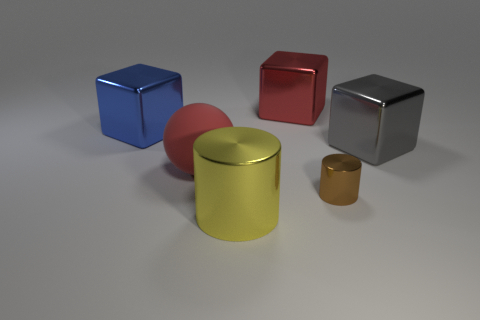Subtract all red metallic cubes. How many cubes are left? 2 Add 3 big gray objects. How many objects exist? 9 Subtract all gray cubes. How many cubes are left? 2 Subtract all cylinders. How many objects are left? 4 Add 3 shiny things. How many shiny things are left? 8 Add 6 large blue shiny blocks. How many large blue shiny blocks exist? 7 Subtract 0 purple spheres. How many objects are left? 6 Subtract all green cubes. Subtract all green balls. How many cubes are left? 3 Subtract all big yellow objects. Subtract all large objects. How many objects are left? 0 